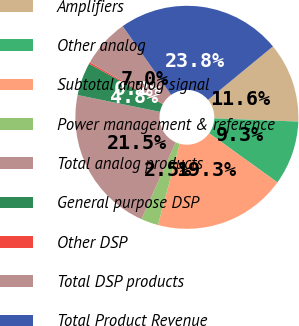Convert chart to OTSL. <chart><loc_0><loc_0><loc_500><loc_500><pie_chart><fcel>Amplifiers<fcel>Other analog<fcel>Subtotal analog signal<fcel>Power management & reference<fcel>Total analog products<fcel>General purpose DSP<fcel>Other DSP<fcel>Total DSP products<fcel>Total Product Revenue<nl><fcel>11.58%<fcel>9.31%<fcel>19.26%<fcel>2.5%<fcel>21.53%<fcel>4.77%<fcel>0.23%<fcel>7.04%<fcel>23.8%<nl></chart> 